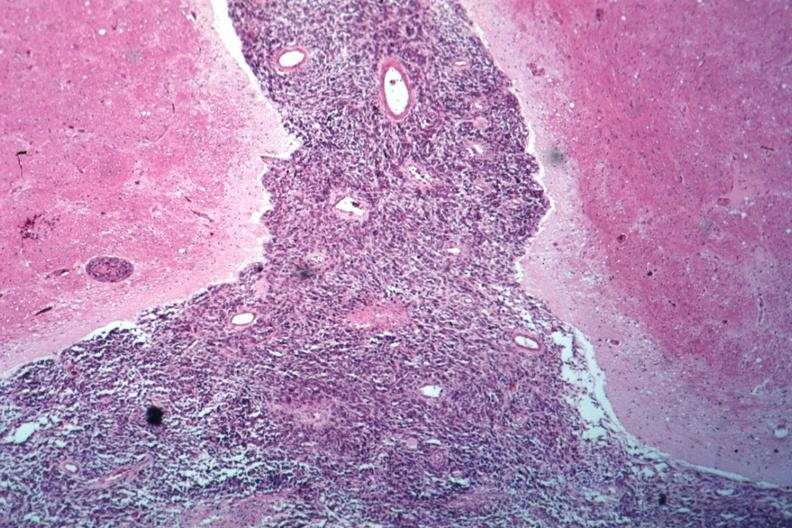s carcinomatous meningitis present?
Answer the question using a single word or phrase. Yes 